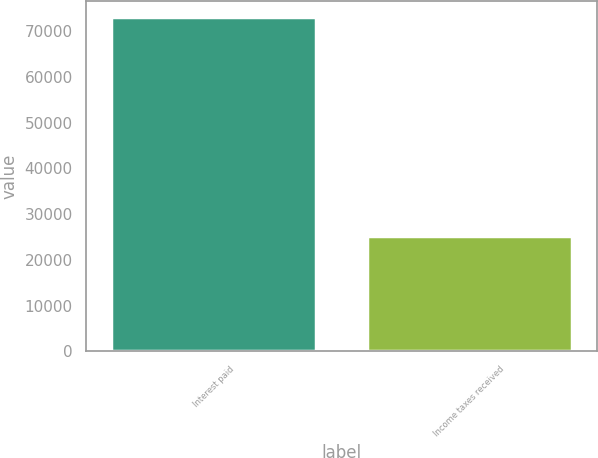Convert chart. <chart><loc_0><loc_0><loc_500><loc_500><bar_chart><fcel>Interest paid<fcel>Income taxes received<nl><fcel>73031<fcel>25202<nl></chart> 